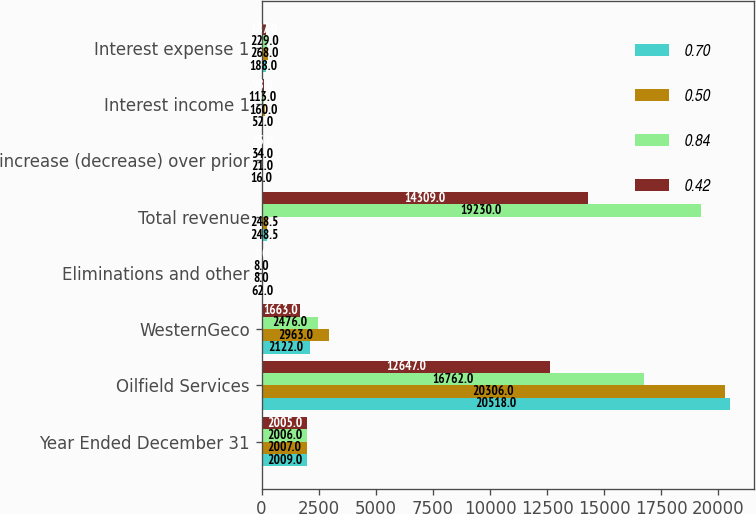<chart> <loc_0><loc_0><loc_500><loc_500><stacked_bar_chart><ecel><fcel>Year Ended December 31<fcel>Oilfield Services<fcel>WesternGeco<fcel>Eliminations and other<fcel>Total revenue<fcel>increase (decrease) over prior<fcel>Interest income 1<fcel>Interest expense 1<nl><fcel>0.7<fcel>2009<fcel>20518<fcel>2122<fcel>62<fcel>248.5<fcel>16<fcel>52<fcel>188<nl><fcel>0.5<fcel>2007<fcel>20306<fcel>2963<fcel>8<fcel>248.5<fcel>21<fcel>160<fcel>268<nl><fcel>0.84<fcel>2006<fcel>16762<fcel>2476<fcel>8<fcel>19230<fcel>34<fcel>113<fcel>229<nl><fcel>0.42<fcel>2005<fcel>12647<fcel>1663<fcel>1<fcel>14309<fcel>25<fcel>98<fcel>187<nl></chart> 